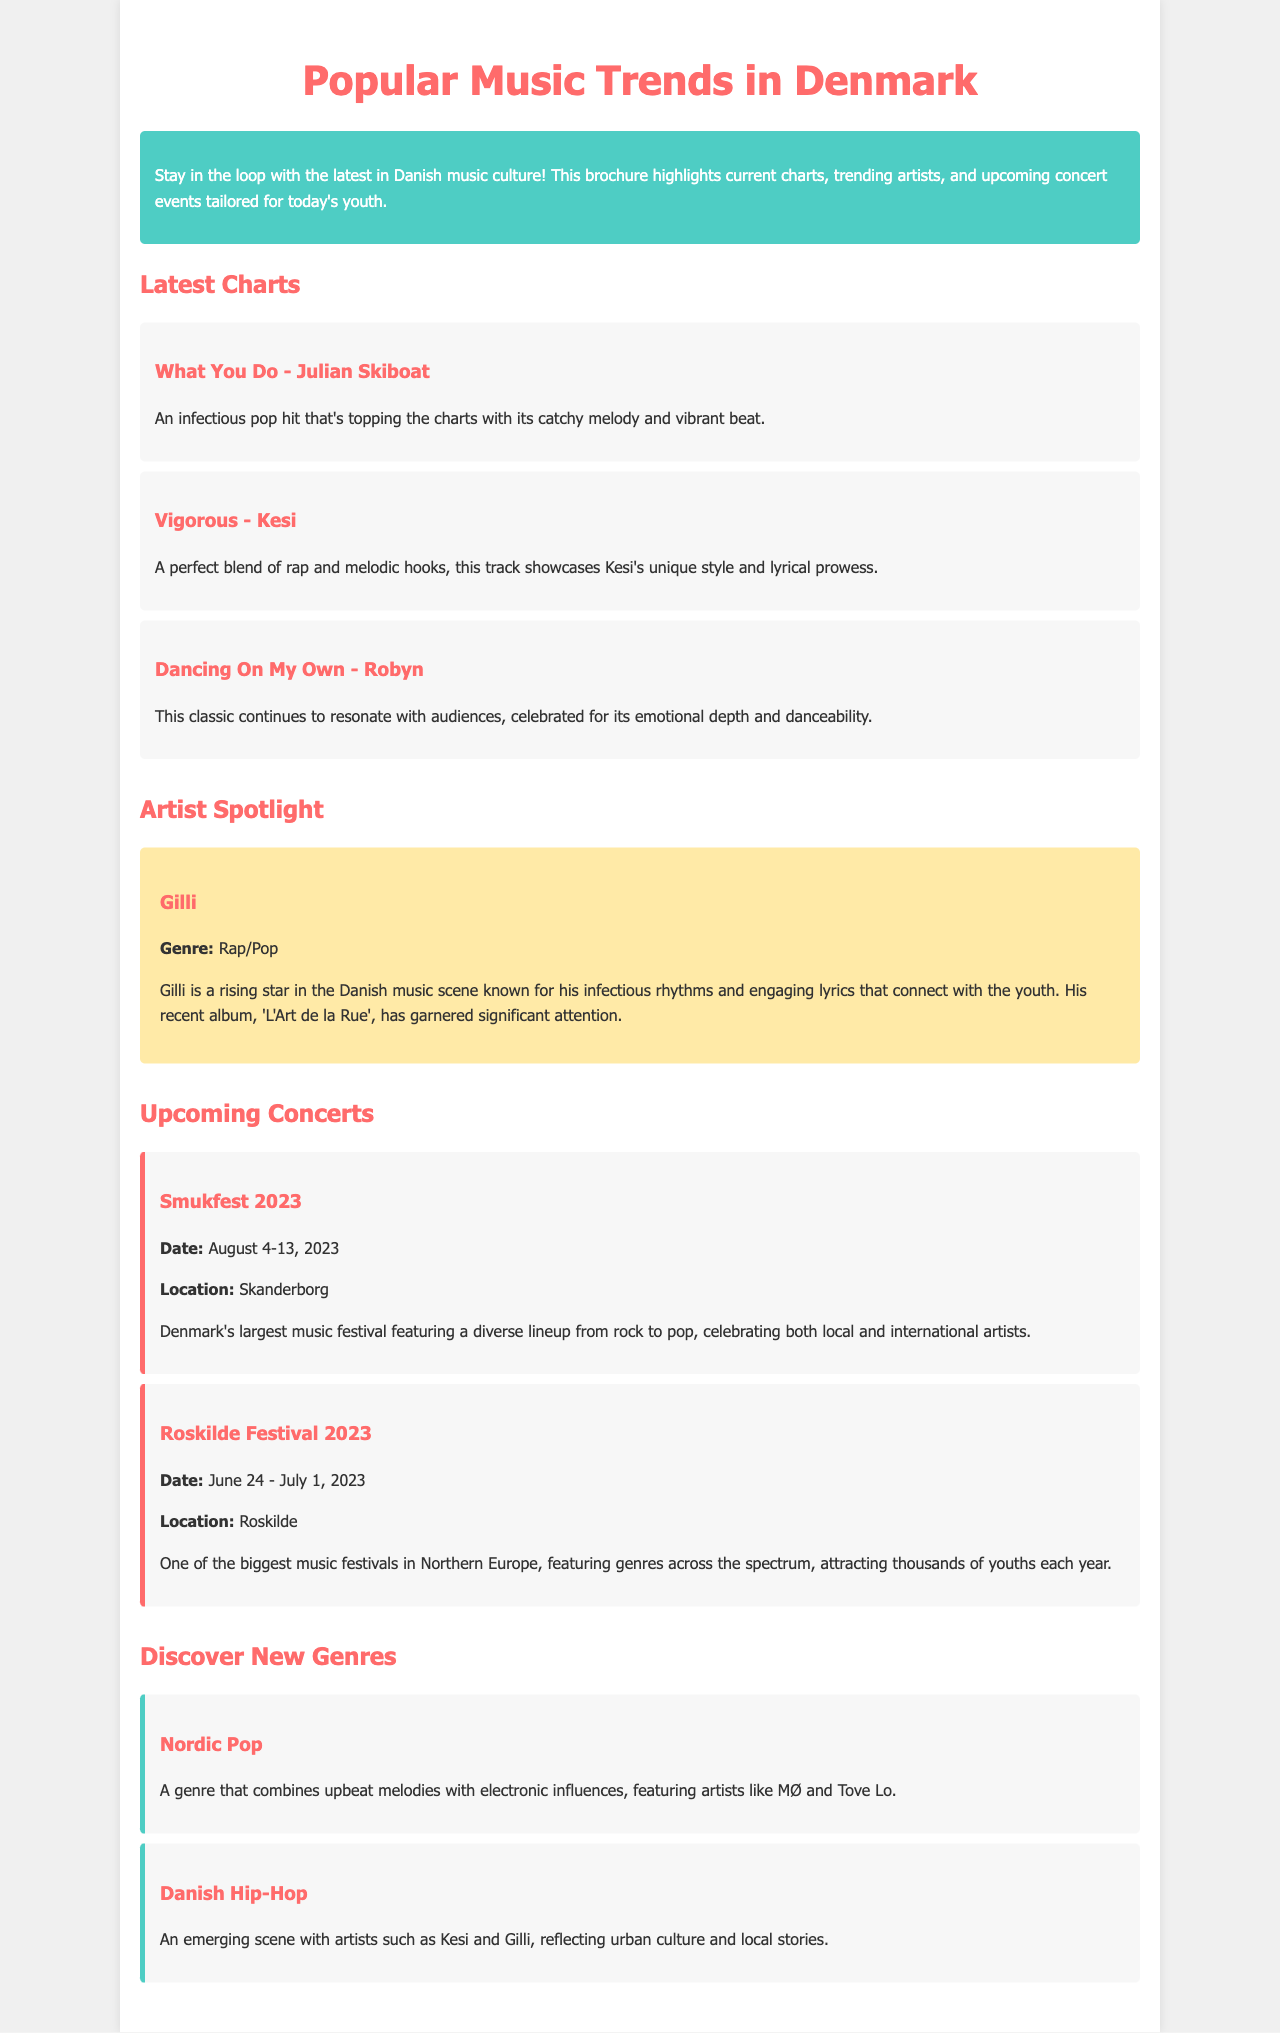What is the title of the brochure? The title of the brochure is prominently featured at the top, clearly stating the topic it covers.
Answer: Popular Music Trends in Denmark Who is the artist of the song "What You Do"? The document includes a section listing the latest charts, each with the song title and artist name.
Answer: Julian Skiboat What genre is Gilli associated with? The artist spotlight section provides details about Gilli including his musical genre.
Answer: Rap/Pop When does Smukfest 2023 take place? The upcoming concerts section has specific dates for each festival, making it easy to find when they occur.
Answer: August 4-13, 2023 What is a characteristic of Nordic Pop? The document describes new genres, focusing on key features that define each genre.
Answer: Upbeat melodies with electronic influences Which festival is mentioned in the document as attracting thousands of youths each year? The events section highlights popular festivals and their appeal to the youth demographic.
Answer: Roskilde Festival 2023 Name one artist featured in Danish Hip-Hop. The document lists artists representing specific genres, particularly focusing on the Danish Hip-Hop scene.
Answer: Kesi What is the main purpose of this brochure? The introduction paragraph summarizes the overall aim and audience for the brochure.
Answer: To help youth stay updated on music 